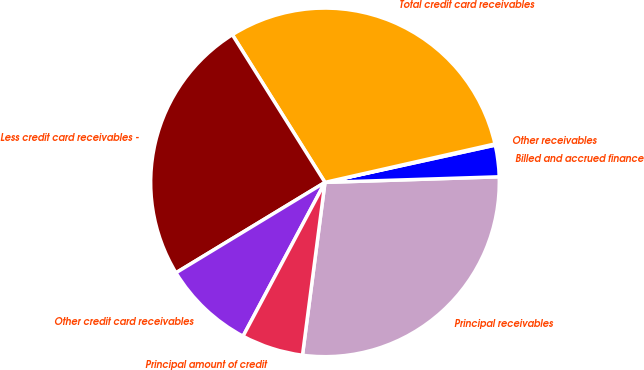Convert chart to OTSL. <chart><loc_0><loc_0><loc_500><loc_500><pie_chart><fcel>Principal receivables<fcel>Billed and accrued finance<fcel>Other receivables<fcel>Total credit card receivables<fcel>Less credit card receivables -<fcel>Other credit card receivables<fcel>Principal amount of credit<nl><fcel>27.57%<fcel>2.92%<fcel>0.11%<fcel>30.38%<fcel>24.76%<fcel>8.53%<fcel>5.73%<nl></chart> 